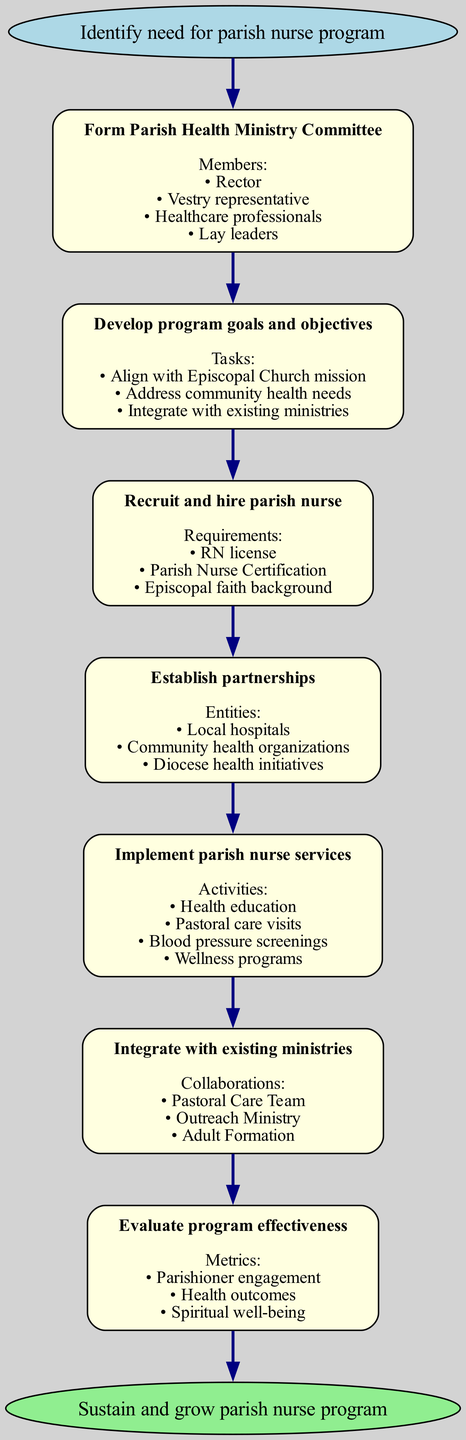What is the starting point of the clinical pathway? The starting point is defined in the diagram as "Identify need for parish nurse program". There is no additional information provided before this node, making it the origin of the pathway.
Answer: Identify need for parish nurse program How many steps are in the pathway? By counting each listed step within the diagram, we find there are a total of 7 distinct steps. These steps are the main activities listed from forming the committee to evaluating the program.
Answer: 7 Who are the members of the Parish Health Ministry Committee? The diagram lists four specific members involved in this committee: the Rector, Vestry representative, Healthcare professionals, and Lay leaders. This information is associated with the first step of forming the committee.
Answer: Rector, Vestry representative, Healthcare professionals, Lay leaders What are the program goals related to the parish nurse program? The program goals include three main tasks: Align with Episcopal Church mission, Address community health needs, and Integrate with existing ministries. These tasks are outlined in the second step of the pathway.
Answer: Align with Episcopal Church mission, Address community health needs, Integrate with existing ministries What is one activity included in the implementation of parish nurse services? The diagram lists multiple activities under the implementation stage, one of which is "Blood pressure screenings". This activity falls under the fifth step of the pathway focused on implementing services.
Answer: Blood pressure screenings Which component collaborates with the parish nurse program? The diagram mentions three collaborations in the integration step: Pastoral Care Team, Outreach Ministry, and Adult Formation. One such component that collaborates with the parish nurse program is the Pastoral Care Team.
Answer: Pastoral Care Team What are the metrics used to evaluate program effectiveness? The program effectiveness evaluation includes three metrics: Parishioner engagement, Health outcomes, and Spiritual well-being. These metrics are specifically detailed in the evaluation step of the pathway.
Answer: Parishioner engagement, Health outcomes, Spiritual well-being What is the final outcome of this clinical pathway? The end point of the pathway is labeled as "Sustain and grow parish nurse program", indicating the ultimate outcome aimed for by following through all the previous steps.
Answer: Sustain and grow parish nurse program 